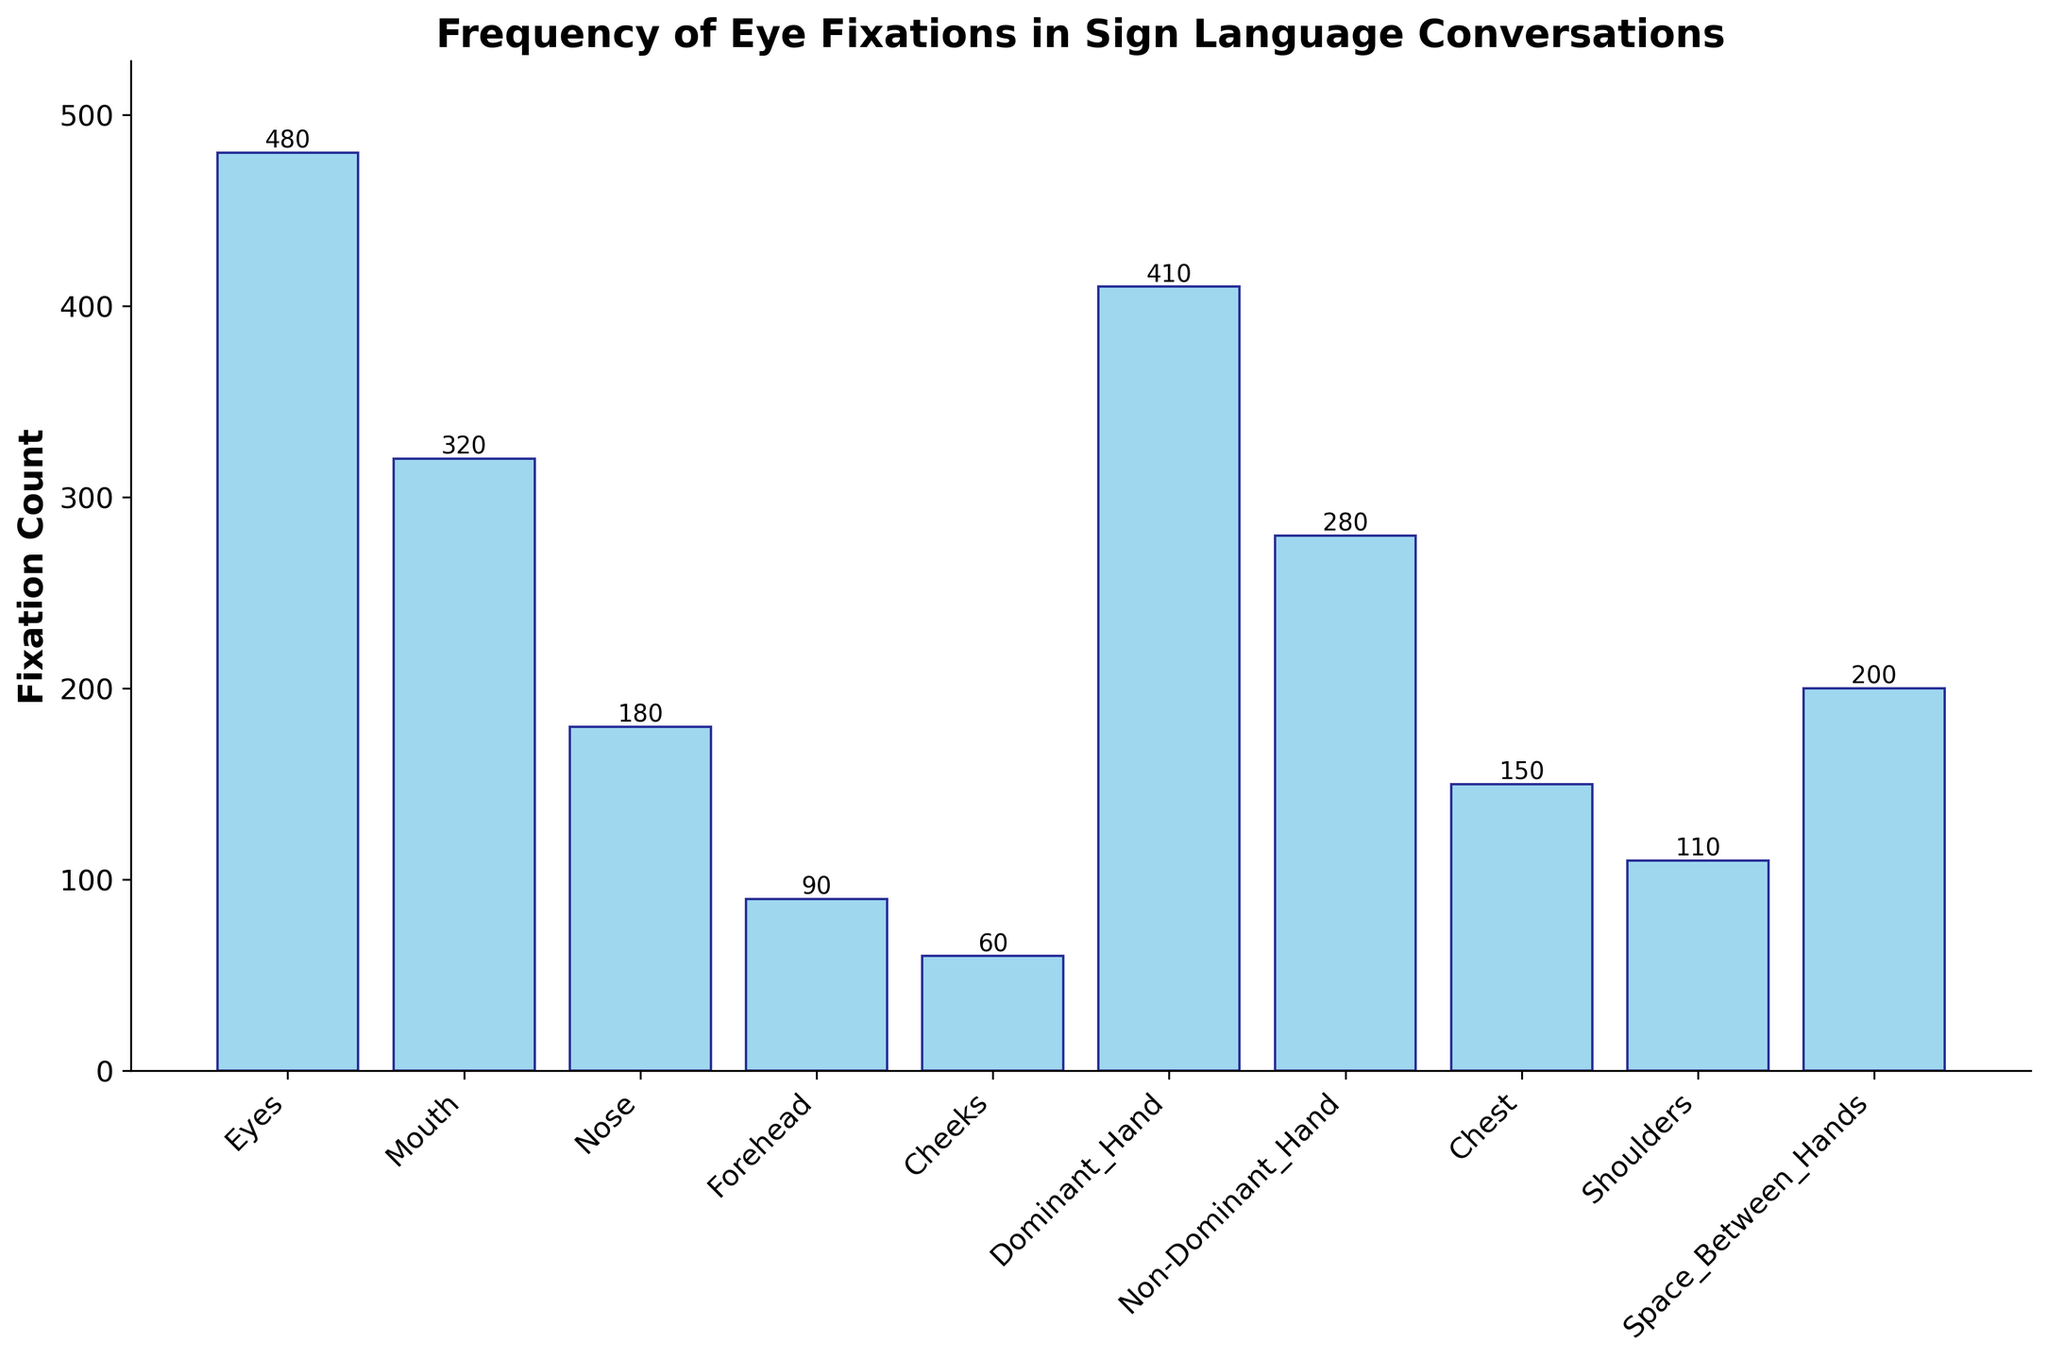What is the total fixation count on the face? The areas of the face are Eyes, Mouth, Nose, Forehead, and Cheeks. Sum their fixation counts: 480 (Eyes) + 320 (Mouth) + 180 (Nose) + 90 (Forehead) + 60 (Cheeks) = 1,130.
Answer: 1,130 Which area has the highest fixation count? By looking at the heights of the bars, the Eyes have the highest bar representing a fixation count of 480.
Answer: Eyes How much higher is the fixation count on Dominant Hand compared to Non-Dominant Hand? The fixation count on Dominant Hand is 410 and on Non-Dominant Hand is 280. Subtract 280 from 410: 410 - 280 = 130.
Answer: 130 What is the average fixation count among all areas? Sum all fixation counts and divide by the number of areas. Total fixation count is 2,280. There are 10 areas. Average is 2,280 / 10 = 228.
Answer: 228 What is the fixation count on areas between hands and shoulders combined? Sum the fixation counts of Space Between Hands and Shoulders: 200 (Space Between Hands) + 110 (Shoulders) = 310.
Answer: 310 Which area has the lowest fixation count? By looking at the heights of the bars, the Cheeks have the lowest bar representing a fixation count of 60.
Answer: Cheeks Are there more fixations on the hands (both) or on the chest? Sum the fixation counts of both hands: 410 (Dominant Hand) + 280 (Non-Dominant Hand) = 690. Compare it to the fixation count on the Chest, which is 150. 690 is greater than 150.
Answer: Hands What is the range of fixation counts? Subtract the smallest fixation count from the largest fixation count. The smallest is 60 (Cheeks) and the largest is 480 (Eyes). Range is 480 - 60 = 420.
Answer: 420 What is the median fixation count? List the fixation counts in ascending order: 60, 90, 110, 150, 180, 200, 280, 320, 410, 480. With 10 values, the median is the average of the 5th and 6th values: (180 + 200) / 2 = 190.
Answer: 190 What portion of the total fixation count is on the Eyes? Fixation count on Eyes is 480. Total fixation count is 2,280. Portion is 480 / 2,280 ≈ 0.2105. Convert to percentage: 0.2105 * 100 ≈ 21.05%.
Answer: 21.05% 